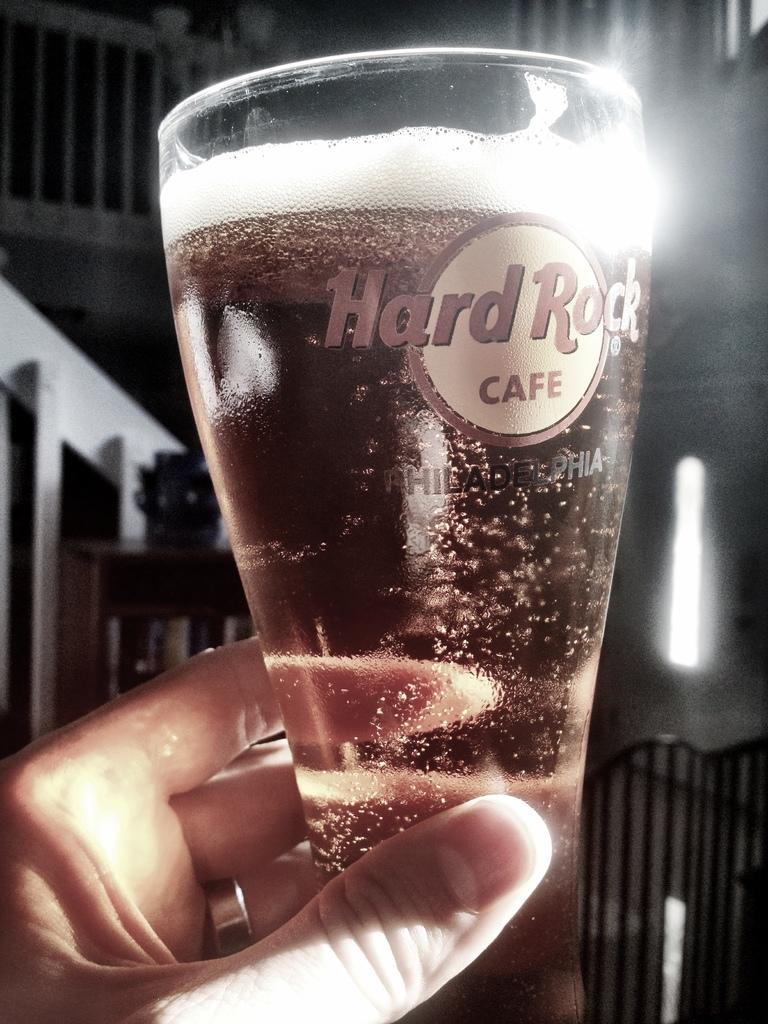<image>
Render a clear and concise summary of the photo. A hand holding a glass with Hard Rock cafe written on it. 